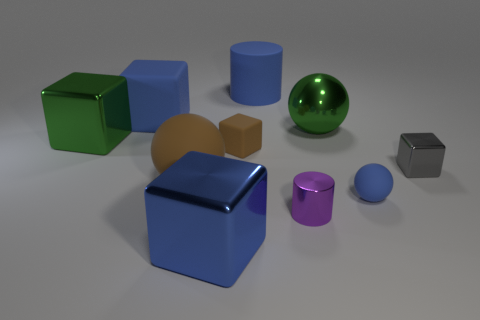Can you tell me the number of cylindrical objects in the image? Certainly, there are two cylindrical objects in the image. One is blue and the other is brown. 